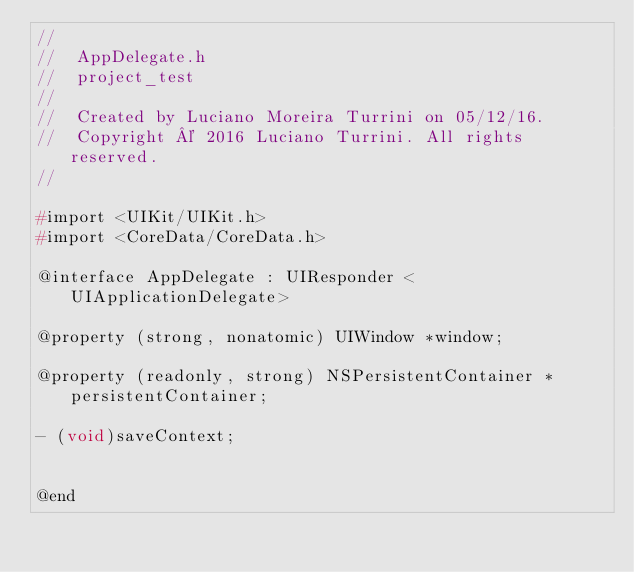<code> <loc_0><loc_0><loc_500><loc_500><_C_>//
//  AppDelegate.h
//  project_test
//
//  Created by Luciano Moreira Turrini on 05/12/16.
//  Copyright © 2016 Luciano Turrini. All rights reserved.
//

#import <UIKit/UIKit.h>
#import <CoreData/CoreData.h>

@interface AppDelegate : UIResponder <UIApplicationDelegate>

@property (strong, nonatomic) UIWindow *window;

@property (readonly, strong) NSPersistentContainer *persistentContainer;

- (void)saveContext;


@end

</code> 